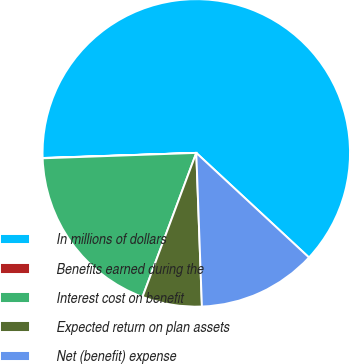<chart> <loc_0><loc_0><loc_500><loc_500><pie_chart><fcel>In millions of dollars<fcel>Benefits earned during the<fcel>Interest cost on benefit<fcel>Expected return on plan assets<fcel>Net (benefit) expense<nl><fcel>62.43%<fcel>0.03%<fcel>18.75%<fcel>6.27%<fcel>12.51%<nl></chart> 